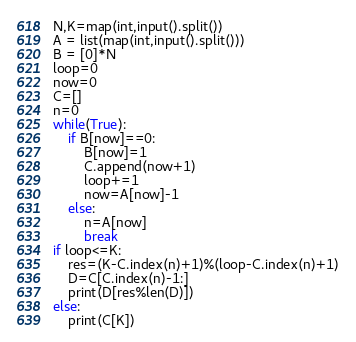Convert code to text. <code><loc_0><loc_0><loc_500><loc_500><_Python_>N,K=map(int,input().split())
A = list(map(int,input().split()))
B = [0]*N
loop=0
now=0
C=[]
n=0
while(True):
    if B[now]==0:
        B[now]=1
        C.append(now+1)
        loop+=1
        now=A[now]-1
    else:
        n=A[now]
        break
if loop<=K:
    res=(K-C.index(n)+1)%(loop-C.index(n)+1)
    D=C[C.index(n)-1:]
    print(D[res%len(D)])
else:
    print(C[K])</code> 